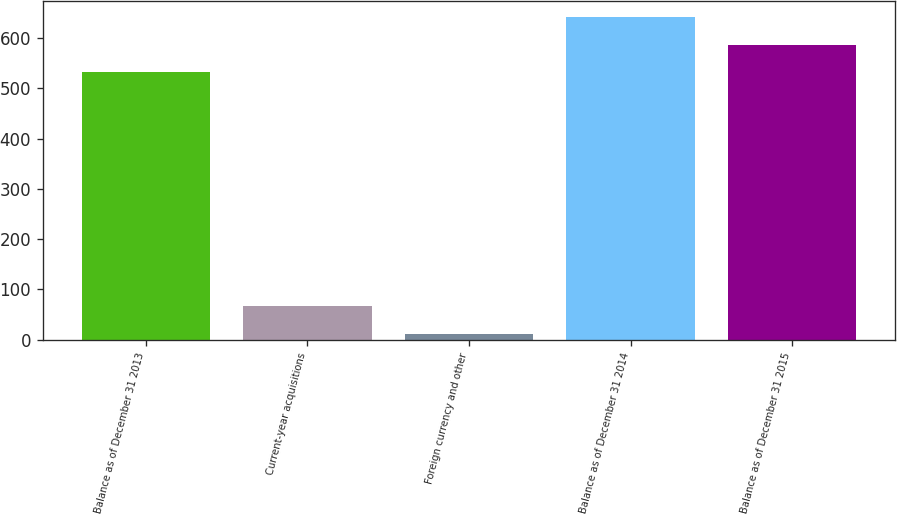Convert chart to OTSL. <chart><loc_0><loc_0><loc_500><loc_500><bar_chart><fcel>Balance as of December 31 2013<fcel>Current-year acquisitions<fcel>Foreign currency and other<fcel>Balance as of December 31 2014<fcel>Balance as of December 31 2015<nl><fcel>532<fcel>67.05<fcel>12.2<fcel>641.7<fcel>586.85<nl></chart> 